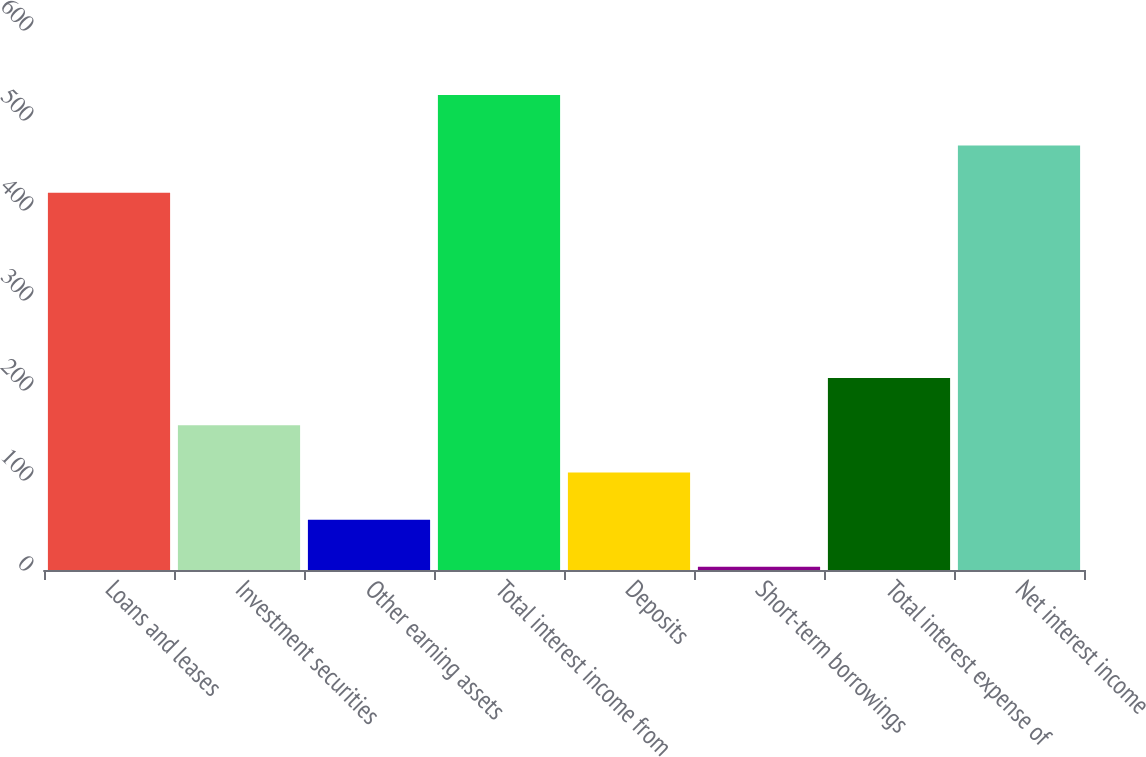<chart> <loc_0><loc_0><loc_500><loc_500><bar_chart><fcel>Loans and leases<fcel>Investment securities<fcel>Other earning assets<fcel>Total interest income from<fcel>Deposits<fcel>Short-term borrowings<fcel>Total interest expense of<fcel>Net interest income<nl><fcel>419.3<fcel>160.79<fcel>55.93<fcel>527.8<fcel>108.36<fcel>3.5<fcel>213.22<fcel>471.73<nl></chart> 